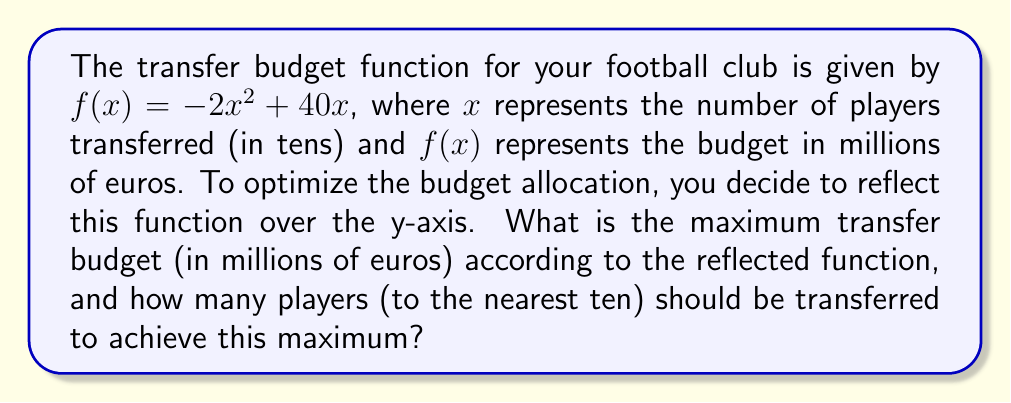Solve this math problem. 1. The original function is $f(x) = -2x^2 + 40x$

2. To reflect the function over the y-axis, we replace $x$ with $-x$:
   $g(x) = -2(-x)^2 + 40(-x) = -2x^2 - 40x$

3. To find the maximum of $g(x)$, we need to find its vertex. For a quadratic function in the form $ax^2 + bx + c$, the x-coordinate of the vertex is given by $-\frac{b}{2a}$

4. In our case, $a = -2$ and $b = -40$:
   $x = -\frac{-40}{2(-2)} = -\frac{-40}{-4} = -10$

5. To find the y-coordinate (maximum budget), we substitute $x = -10$ into $g(x)$:
   $g(-10) = -2(-10)^2 - 40(-10) = -2(100) + 400 = -200 + 400 = 200$

6. Therefore, the maximum budget is 200 million euros.

7. The number of players to be transferred is represented by $|-10|$ (absolute value because we reflected over y-axis) multiplied by 10 (as $x$ was in tens):
   $|-10| \times 10 = 100$ players
Answer: 200 million euros; 100 players 